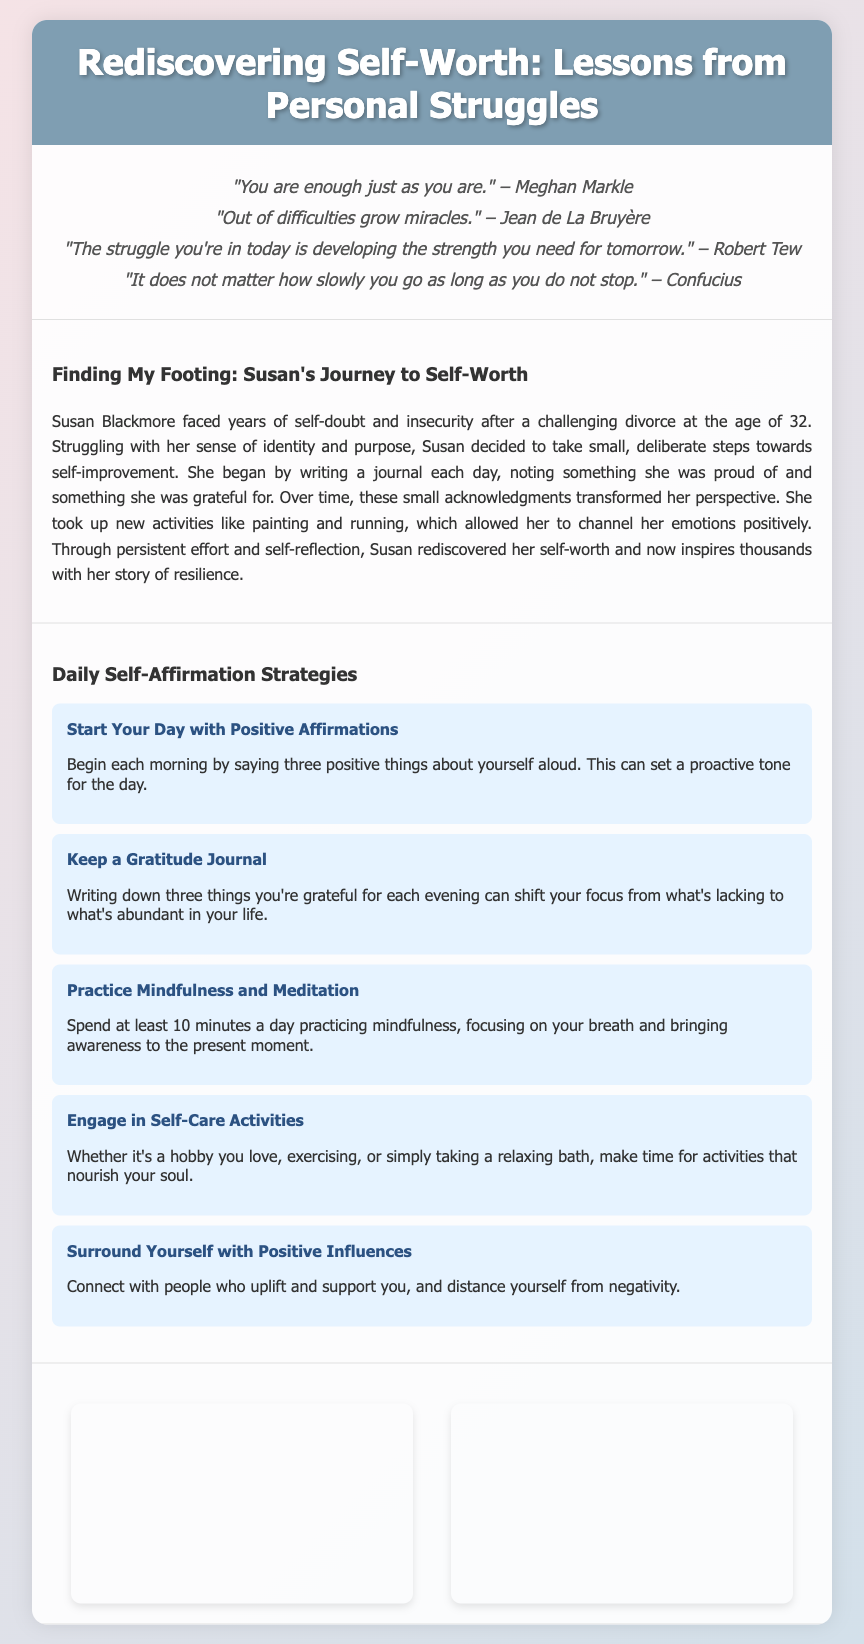What is the title of the flyer? The title of the flyer is displayed prominently at the top of the document.
Answer: Rediscovering Self-Worth: Lessons from Personal Struggles What is Susan's last name in her journey story? Susan's last name is mentioned in the personal story section of the flyer.
Answer: Blackmore How many positive quotes are listed in the quotes section? The number of quotes can be counted in the quotes section of the document.
Answer: Four What is one activity Susan took up to channel her emotions? The document describes activities that Susan engaged in to improve her self-worth.
Answer: Painting What is the length of time suggested for mindfulness practice? The document specifies a time duration for practicing mindfulness in daily strategies.
Answer: Ten minutes What type of imagery is used as a background for the flyer? The flyer features calming visual elements meant to evoke tranquility and inspiration.
Answer: Pastel colors What is a recommended daily affirmation strategy mentioned in the tips? The flyer provides strategies for reinforcing self-worth, including specific affirmations.
Answer: Start Your Day with Positive Affirmations What should be written in a gratitude journal each evening? The content suggested for the gratitude journal is mentioned in the tips for daily self-affirmation strategies.
Answer: Three things you're grateful for What color is the header background of the document? The color of the header background is specified in the document styling section.
Answer: #7f9eb2 